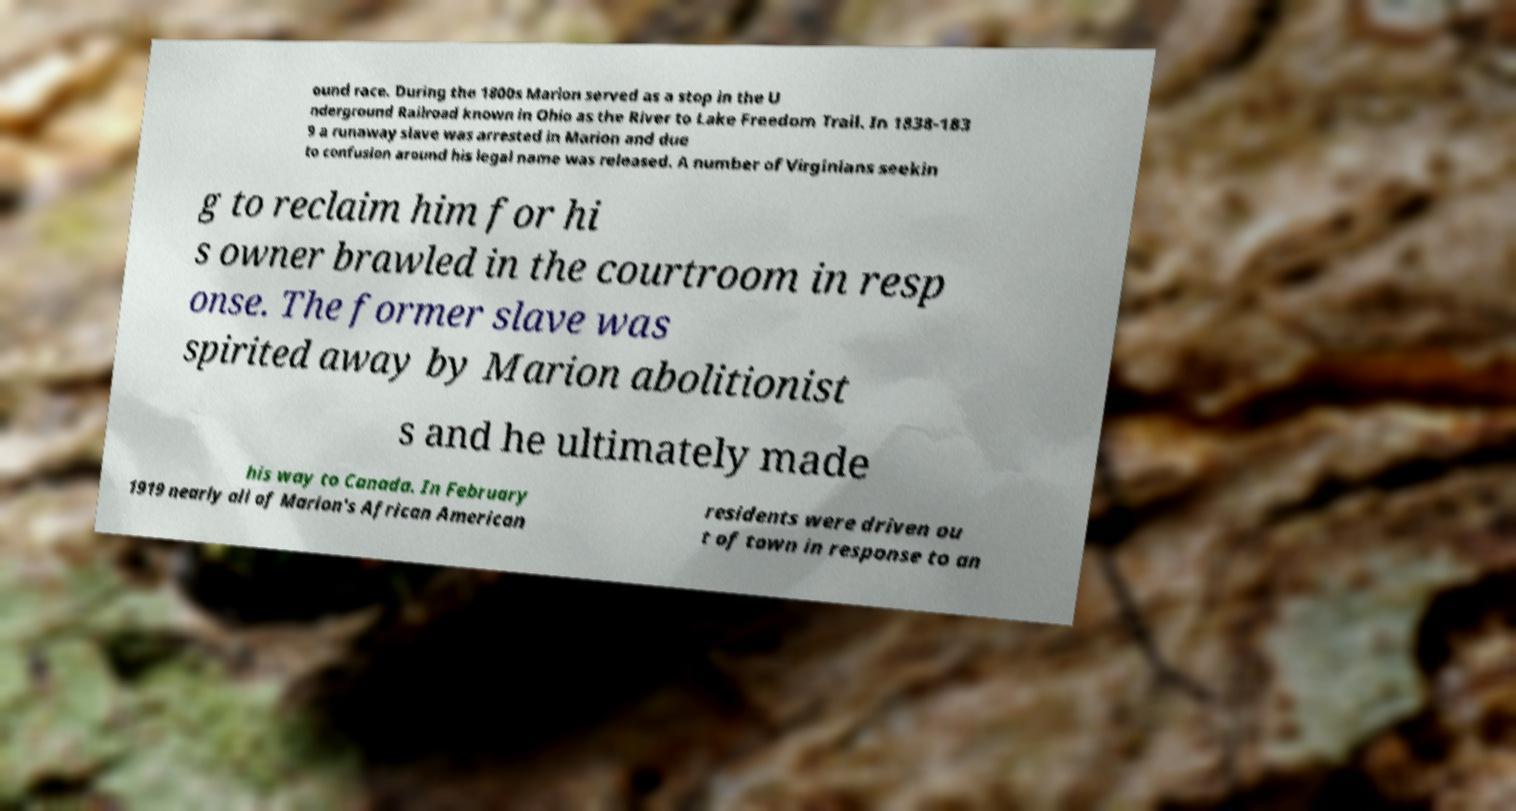Please read and relay the text visible in this image. What does it say? ound race. During the 1800s Marion served as a stop in the U nderground Railroad known in Ohio as the River to Lake Freedom Trail. In 1838-183 9 a runaway slave was arrested in Marion and due to confusion around his legal name was released. A number of Virginians seekin g to reclaim him for hi s owner brawled in the courtroom in resp onse. The former slave was spirited away by Marion abolitionist s and he ultimately made his way to Canada. In February 1919 nearly all of Marion's African American residents were driven ou t of town in response to an 